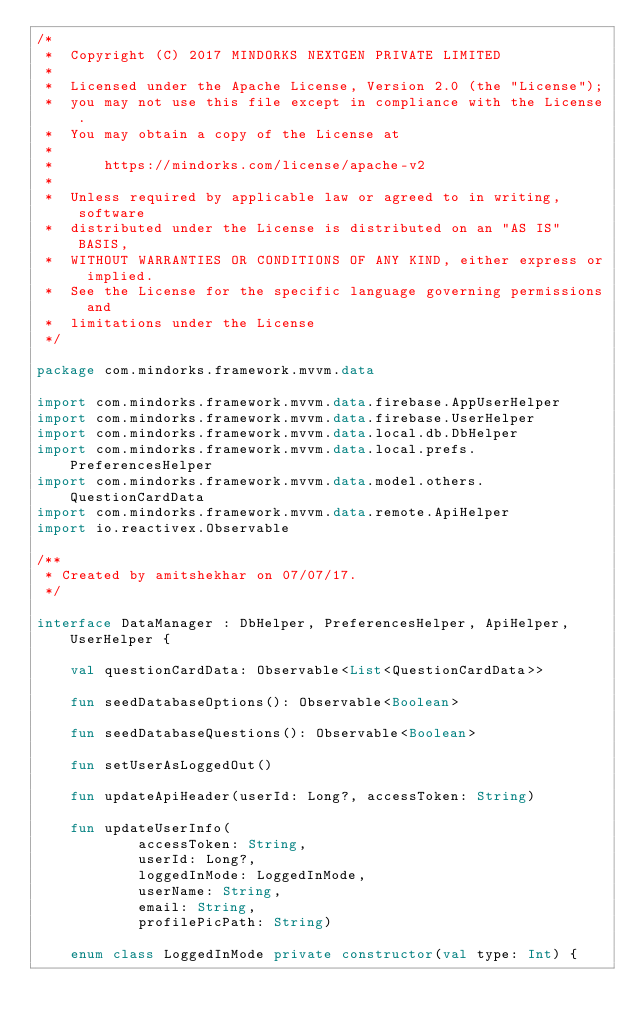<code> <loc_0><loc_0><loc_500><loc_500><_Kotlin_>/*
 *  Copyright (C) 2017 MINDORKS NEXTGEN PRIVATE LIMITED
 *
 *  Licensed under the Apache License, Version 2.0 (the "License");
 *  you may not use this file except in compliance with the License.
 *  You may obtain a copy of the License at
 *
 *      https://mindorks.com/license/apache-v2
 *
 *  Unless required by applicable law or agreed to in writing, software
 *  distributed under the License is distributed on an "AS IS" BASIS,
 *  WITHOUT WARRANTIES OR CONDITIONS OF ANY KIND, either express or implied.
 *  See the License for the specific language governing permissions and
 *  limitations under the License
 */

package com.mindorks.framework.mvvm.data

import com.mindorks.framework.mvvm.data.firebase.AppUserHelper
import com.mindorks.framework.mvvm.data.firebase.UserHelper
import com.mindorks.framework.mvvm.data.local.db.DbHelper
import com.mindorks.framework.mvvm.data.local.prefs.PreferencesHelper
import com.mindorks.framework.mvvm.data.model.others.QuestionCardData
import com.mindorks.framework.mvvm.data.remote.ApiHelper
import io.reactivex.Observable

/**
 * Created by amitshekhar on 07/07/17.
 */

interface DataManager : DbHelper, PreferencesHelper, ApiHelper, UserHelper {

    val questionCardData: Observable<List<QuestionCardData>>

    fun seedDatabaseOptions(): Observable<Boolean>

    fun seedDatabaseQuestions(): Observable<Boolean>

    fun setUserAsLoggedOut()

    fun updateApiHeader(userId: Long?, accessToken: String)

    fun updateUserInfo(
            accessToken: String,
            userId: Long?,
            loggedInMode: LoggedInMode,
            userName: String,
            email: String,
            profilePicPath: String)

    enum class LoggedInMode private constructor(val type: Int) {
</code> 